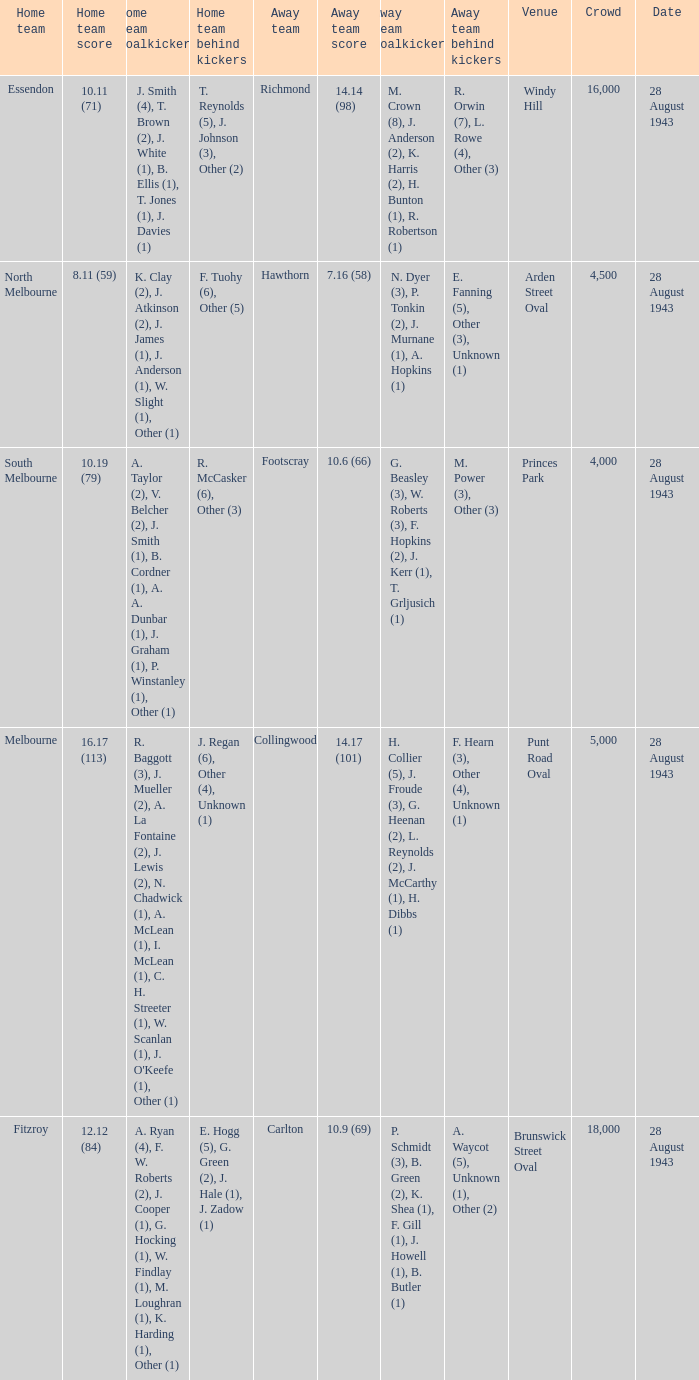Where was the game played with an away team score of 14.17 (101)? Punt Road Oval. 